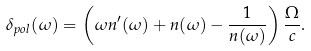<formula> <loc_0><loc_0><loc_500><loc_500>\delta _ { p o l } ( \omega ) = \left ( \omega n ^ { \prime } ( \omega ) + n ( \omega ) - \frac { 1 } { n ( \omega ) } \right ) \frac { \Omega } { c } .</formula> 